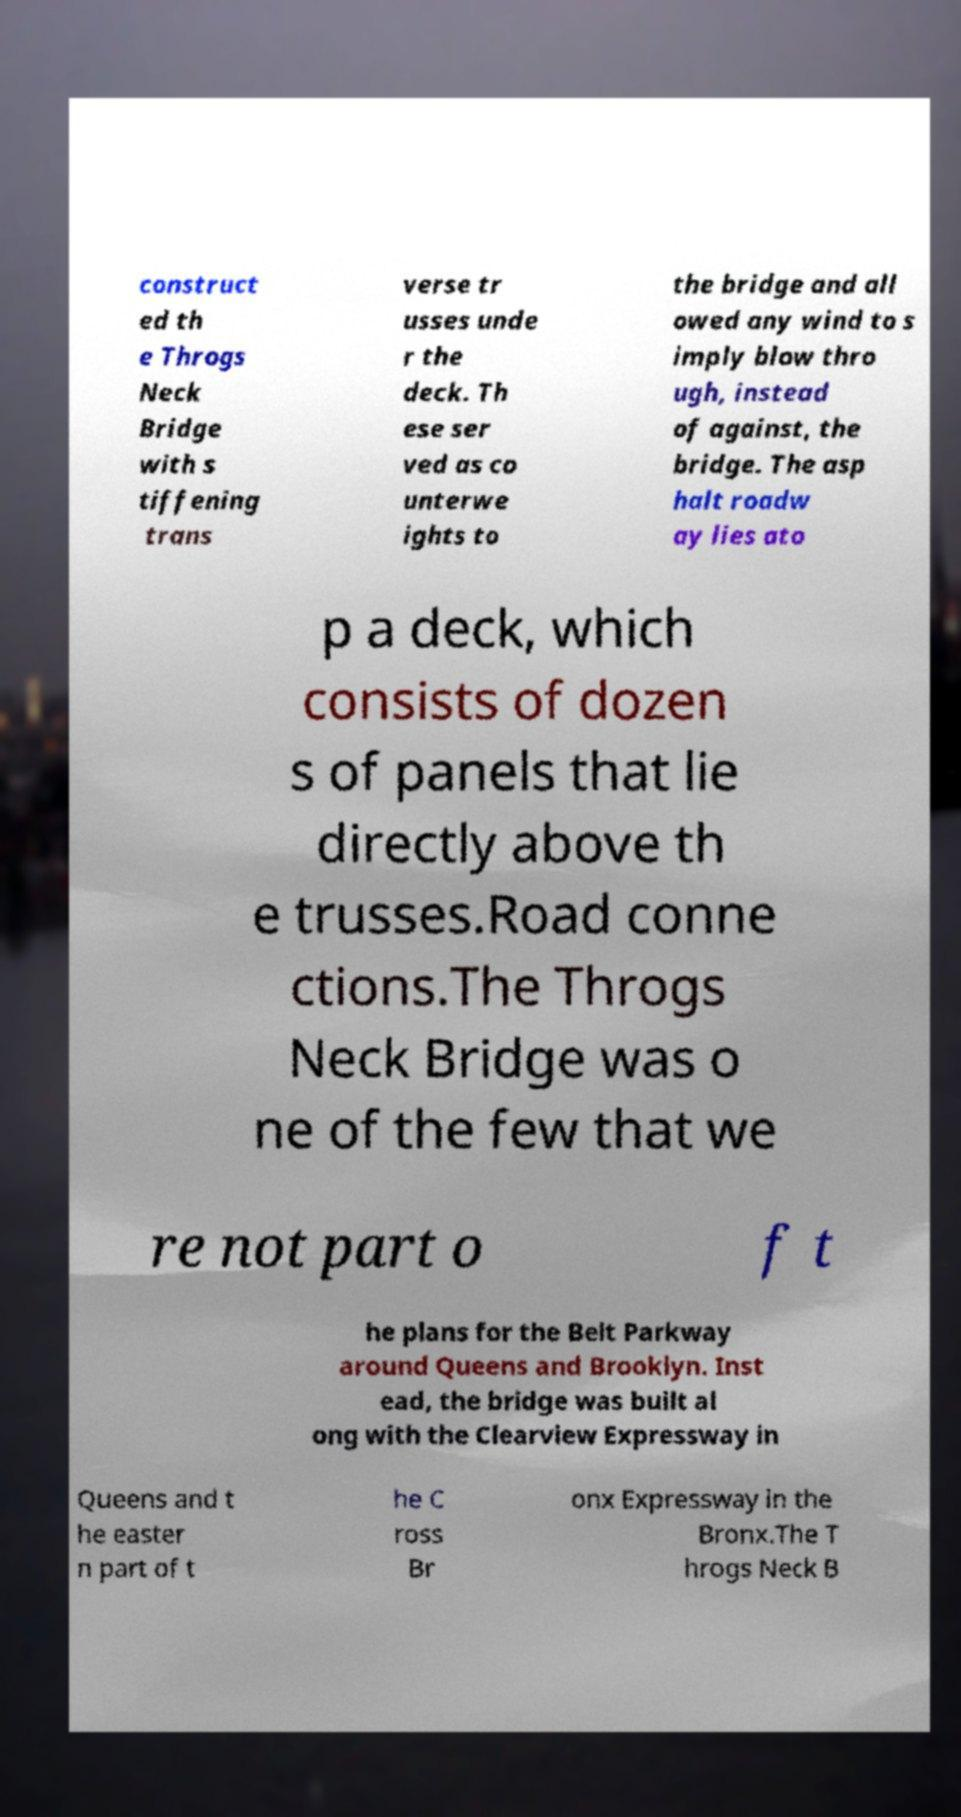Could you extract and type out the text from this image? construct ed th e Throgs Neck Bridge with s tiffening trans verse tr usses unde r the deck. Th ese ser ved as co unterwe ights to the bridge and all owed any wind to s imply blow thro ugh, instead of against, the bridge. The asp halt roadw ay lies ato p a deck, which consists of dozen s of panels that lie directly above th e trusses.Road conne ctions.The Throgs Neck Bridge was o ne of the few that we re not part o f t he plans for the Belt Parkway around Queens and Brooklyn. Inst ead, the bridge was built al ong with the Clearview Expressway in Queens and t he easter n part of t he C ross Br onx Expressway in the Bronx.The T hrogs Neck B 